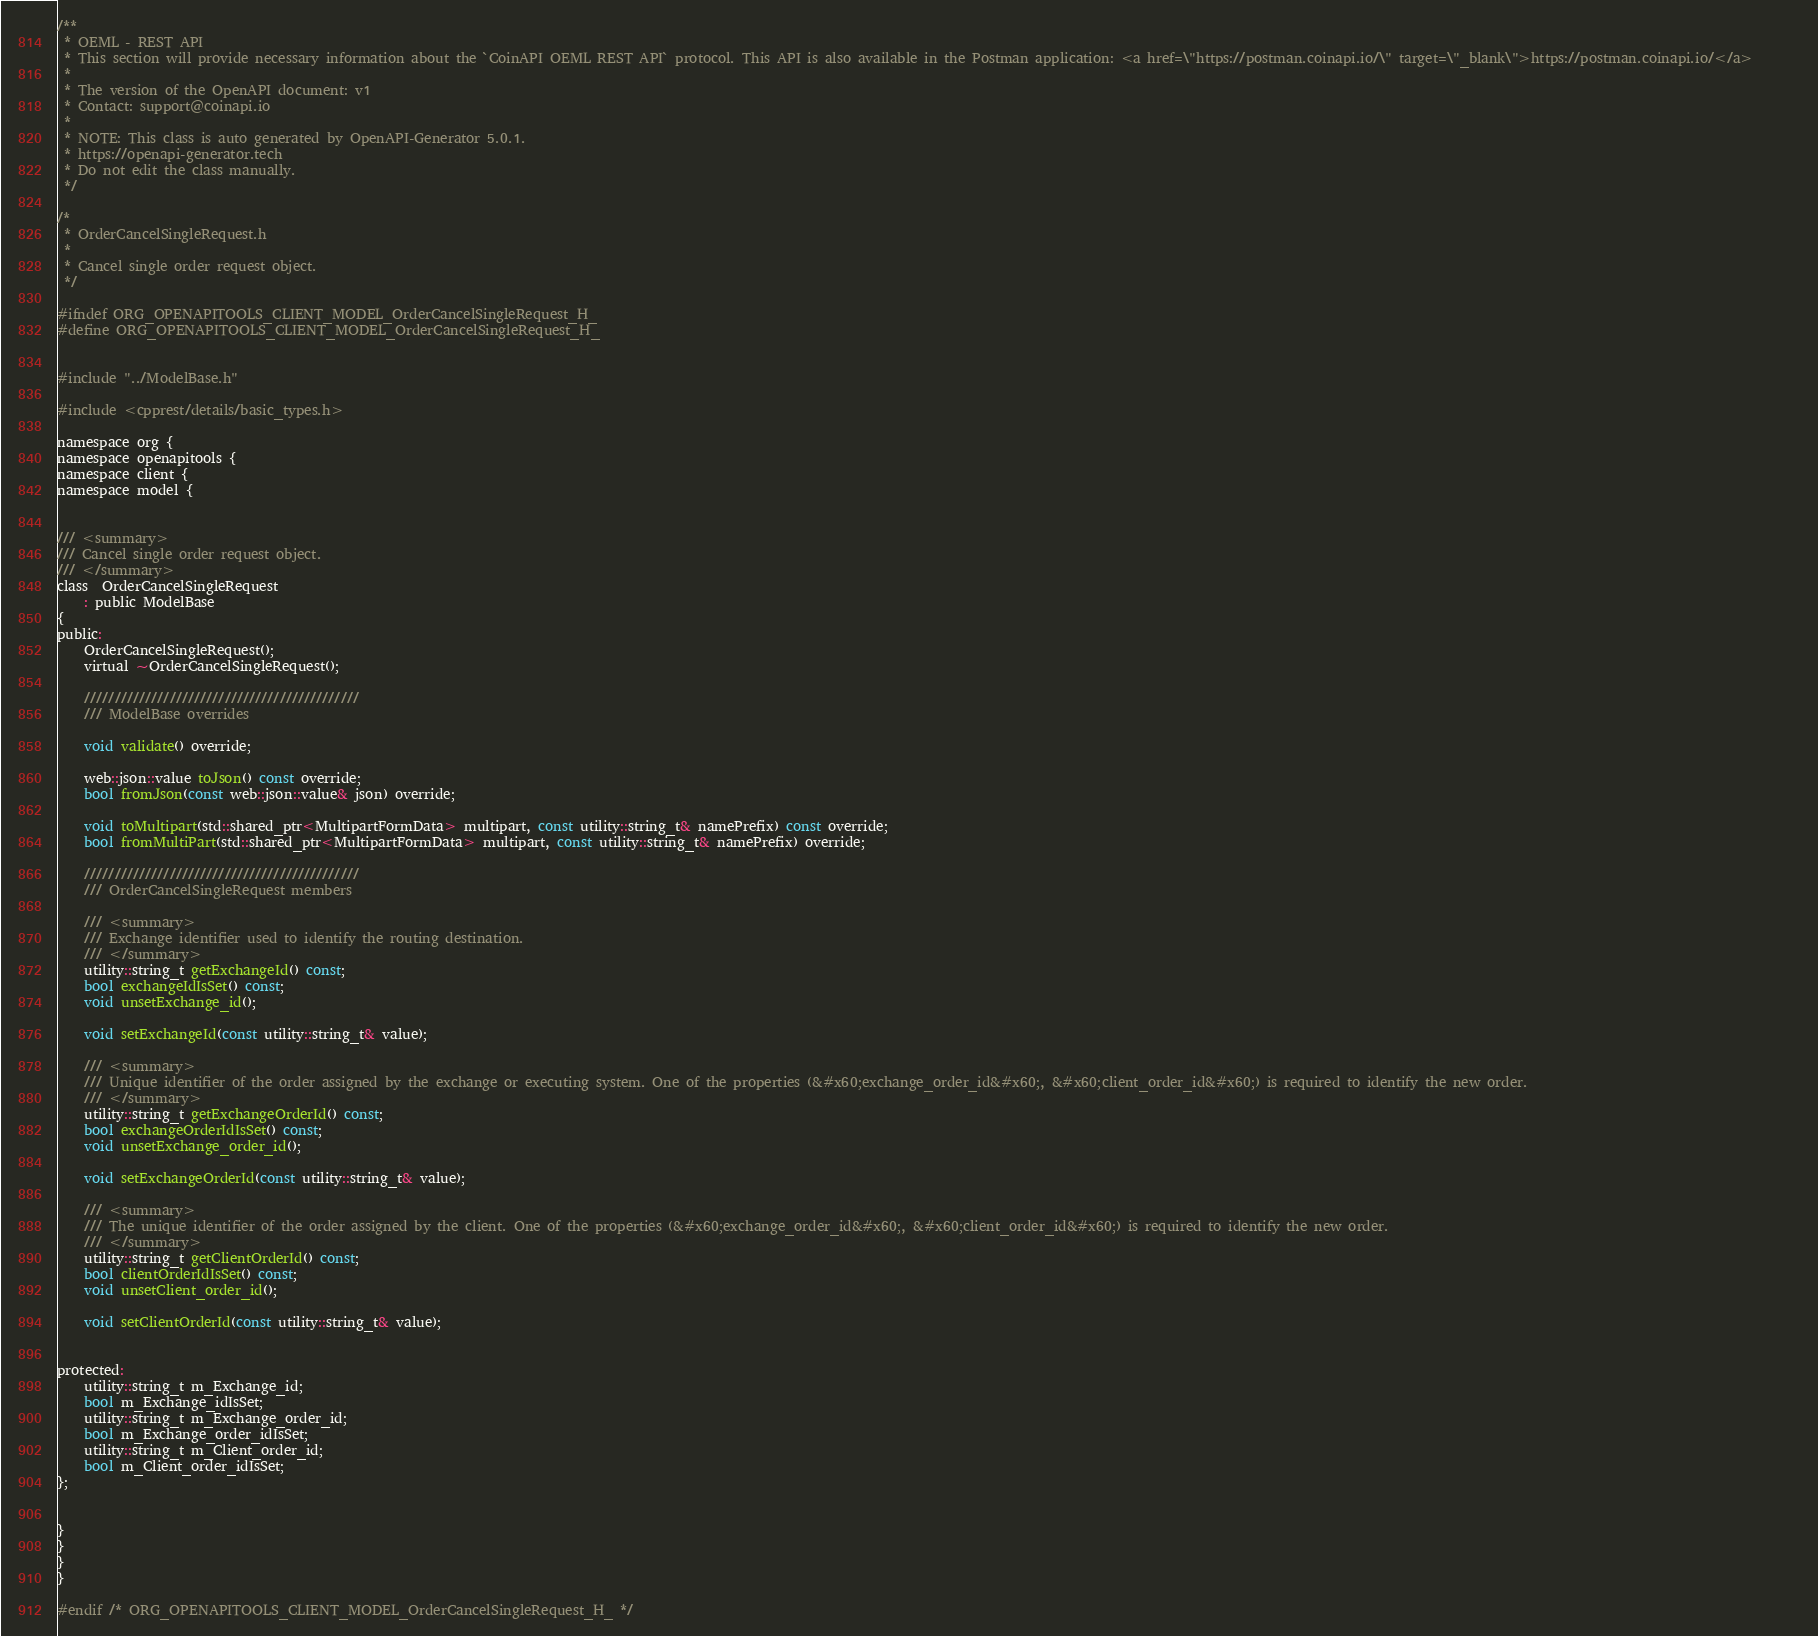<code> <loc_0><loc_0><loc_500><loc_500><_C_>/**
 * OEML - REST API
 * This section will provide necessary information about the `CoinAPI OEML REST API` protocol. This API is also available in the Postman application: <a href=\"https://postman.coinapi.io/\" target=\"_blank\">https://postman.coinapi.io/</a>       
 *
 * The version of the OpenAPI document: v1
 * Contact: support@coinapi.io
 *
 * NOTE: This class is auto generated by OpenAPI-Generator 5.0.1.
 * https://openapi-generator.tech
 * Do not edit the class manually.
 */

/*
 * OrderCancelSingleRequest.h
 *
 * Cancel single order request object.
 */

#ifndef ORG_OPENAPITOOLS_CLIENT_MODEL_OrderCancelSingleRequest_H_
#define ORG_OPENAPITOOLS_CLIENT_MODEL_OrderCancelSingleRequest_H_


#include "../ModelBase.h"

#include <cpprest/details/basic_types.h>

namespace org {
namespace openapitools {
namespace client {
namespace model {


/// <summary>
/// Cancel single order request object.
/// </summary>
class  OrderCancelSingleRequest
    : public ModelBase
{
public:
    OrderCancelSingleRequest();
    virtual ~OrderCancelSingleRequest();

    /////////////////////////////////////////////
    /// ModelBase overrides

    void validate() override;

    web::json::value toJson() const override;
    bool fromJson(const web::json::value& json) override;

    void toMultipart(std::shared_ptr<MultipartFormData> multipart, const utility::string_t& namePrefix) const override;
    bool fromMultiPart(std::shared_ptr<MultipartFormData> multipart, const utility::string_t& namePrefix) override;

    /////////////////////////////////////////////
    /// OrderCancelSingleRequest members

    /// <summary>
    /// Exchange identifier used to identify the routing destination.
    /// </summary>
    utility::string_t getExchangeId() const;
    bool exchangeIdIsSet() const;
    void unsetExchange_id();

    void setExchangeId(const utility::string_t& value);

    /// <summary>
    /// Unique identifier of the order assigned by the exchange or executing system. One of the properties (&#x60;exchange_order_id&#x60;, &#x60;client_order_id&#x60;) is required to identify the new order.
    /// </summary>
    utility::string_t getExchangeOrderId() const;
    bool exchangeOrderIdIsSet() const;
    void unsetExchange_order_id();

    void setExchangeOrderId(const utility::string_t& value);

    /// <summary>
    /// The unique identifier of the order assigned by the client. One of the properties (&#x60;exchange_order_id&#x60;, &#x60;client_order_id&#x60;) is required to identify the new order.
    /// </summary>
    utility::string_t getClientOrderId() const;
    bool clientOrderIdIsSet() const;
    void unsetClient_order_id();

    void setClientOrderId(const utility::string_t& value);


protected:
    utility::string_t m_Exchange_id;
    bool m_Exchange_idIsSet;
    utility::string_t m_Exchange_order_id;
    bool m_Exchange_order_idIsSet;
    utility::string_t m_Client_order_id;
    bool m_Client_order_idIsSet;
};


}
}
}
}

#endif /* ORG_OPENAPITOOLS_CLIENT_MODEL_OrderCancelSingleRequest_H_ */
</code> 